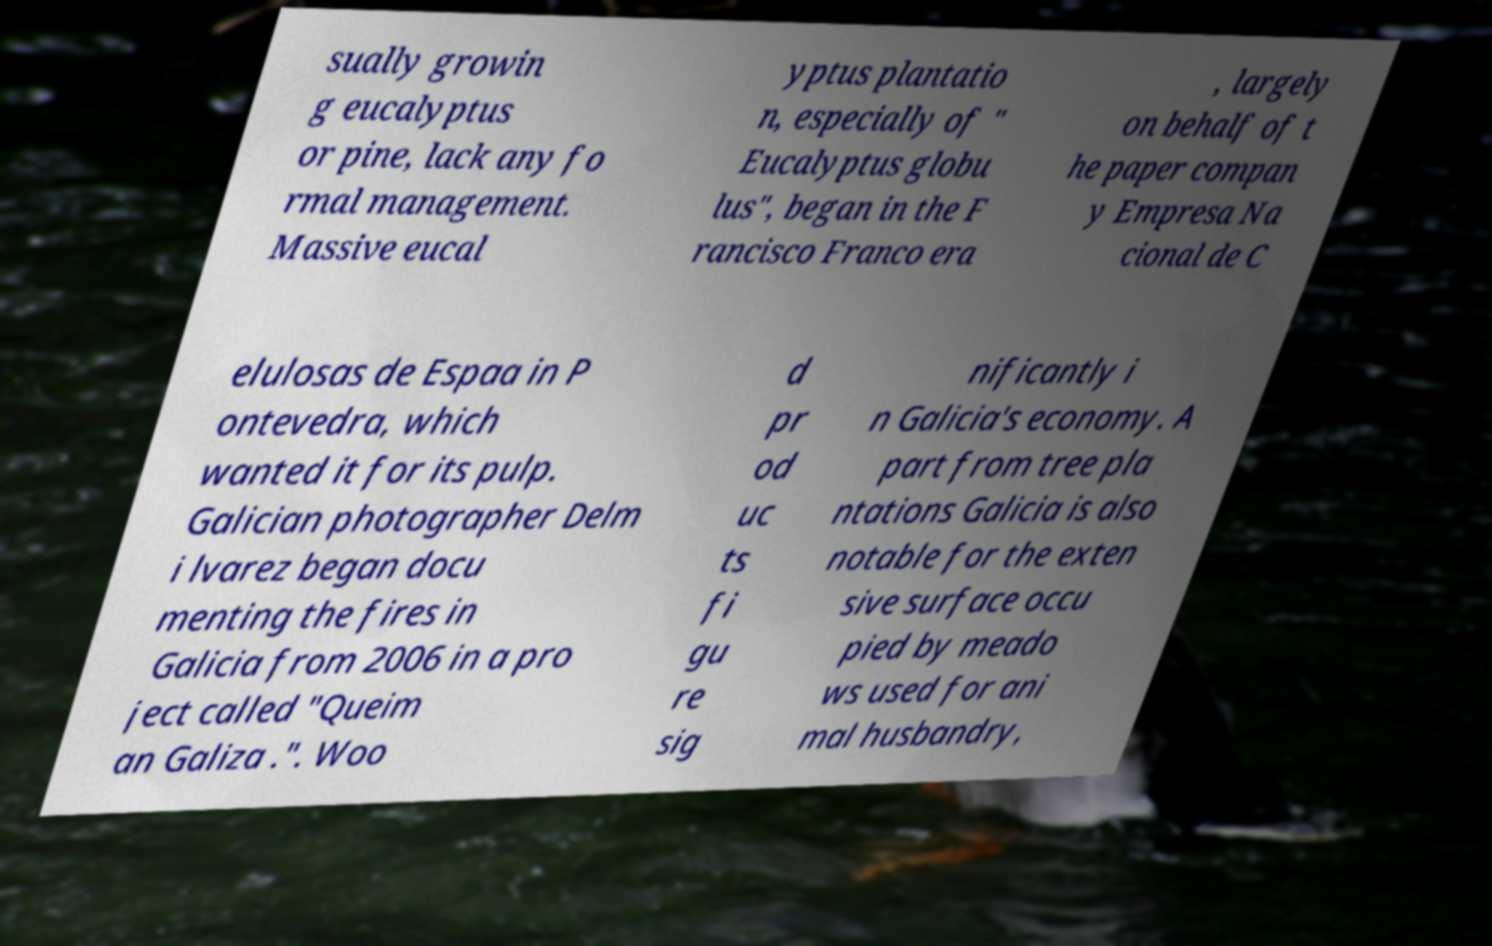Could you extract and type out the text from this image? sually growin g eucalyptus or pine, lack any fo rmal management. Massive eucal yptus plantatio n, especially of " Eucalyptus globu lus", began in the F rancisco Franco era , largely on behalf of t he paper compan y Empresa Na cional de C elulosas de Espaa in P ontevedra, which wanted it for its pulp. Galician photographer Delm i lvarez began docu menting the fires in Galicia from 2006 in a pro ject called "Queim an Galiza .". Woo d pr od uc ts fi gu re sig nificantly i n Galicia's economy. A part from tree pla ntations Galicia is also notable for the exten sive surface occu pied by meado ws used for ani mal husbandry, 